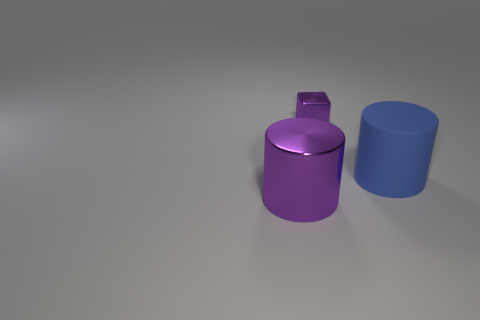Add 3 big purple matte blocks. How many objects exist? 6 Subtract all cylinders. How many objects are left? 1 Subtract 0 green cylinders. How many objects are left? 3 Subtract all cylinders. Subtract all large purple shiny cylinders. How many objects are left? 0 Add 2 large blue matte cylinders. How many large blue matte cylinders are left? 3 Add 2 big red cylinders. How many big red cylinders exist? 2 